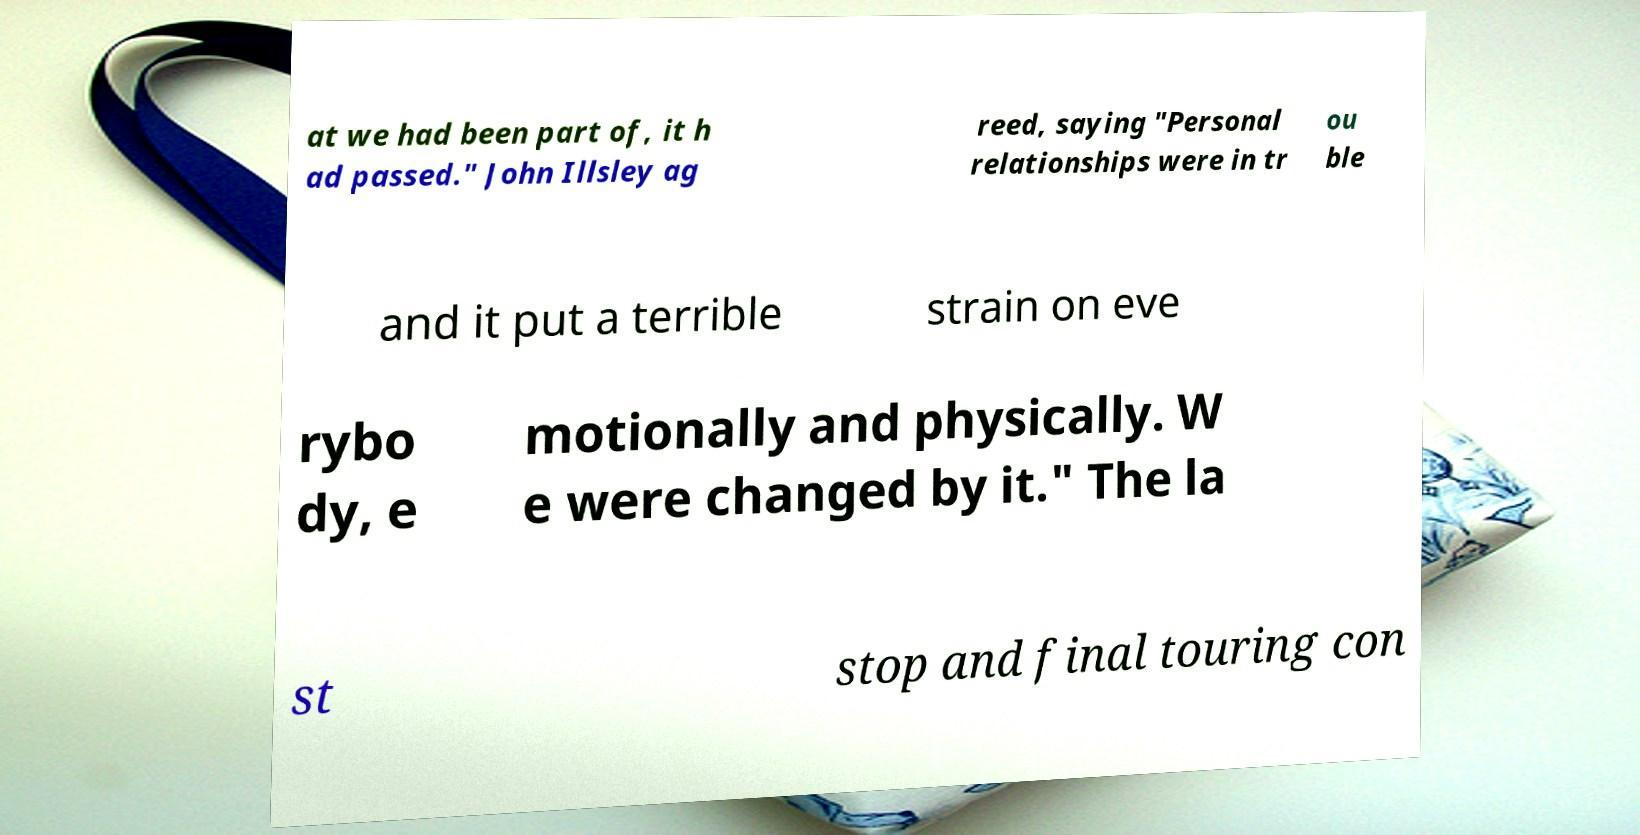For documentation purposes, I need the text within this image transcribed. Could you provide that? at we had been part of, it h ad passed." John Illsley ag reed, saying "Personal relationships were in tr ou ble and it put a terrible strain on eve rybo dy, e motionally and physically. W e were changed by it." The la st stop and final touring con 